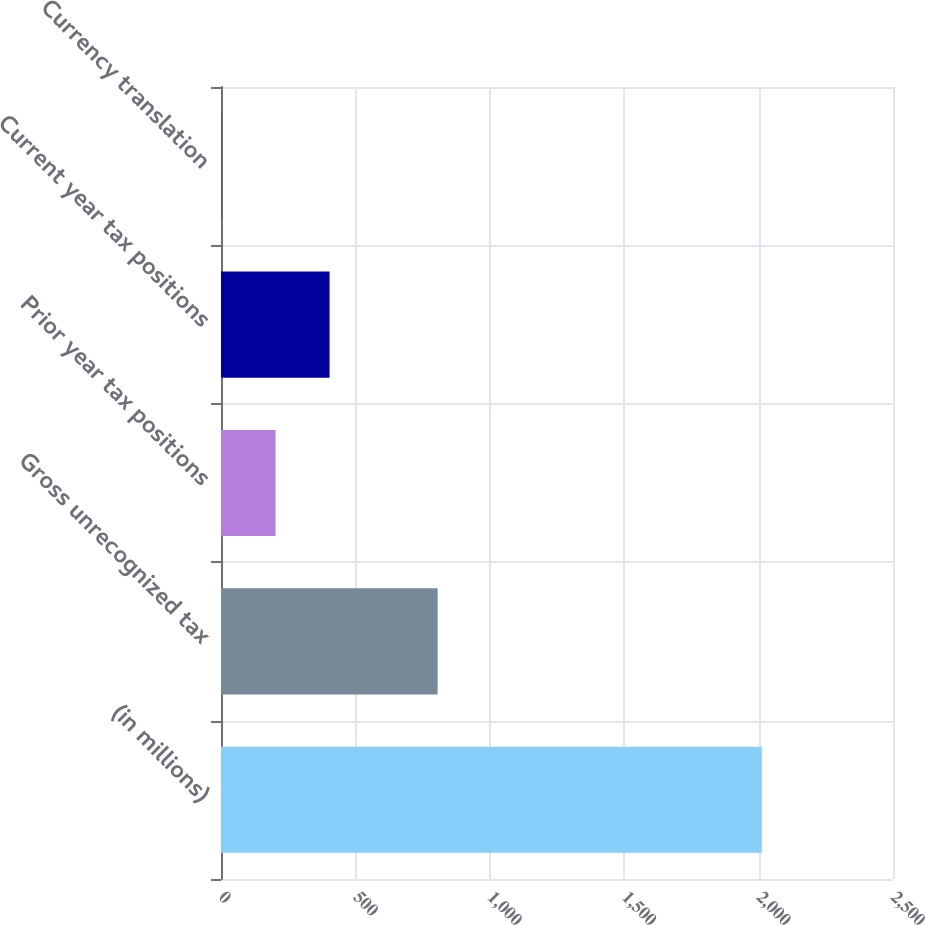<chart> <loc_0><loc_0><loc_500><loc_500><bar_chart><fcel>(in millions)<fcel>Gross unrecognized tax<fcel>Prior year tax positions<fcel>Current year tax positions<fcel>Currency translation<nl><fcel>2012<fcel>805.88<fcel>202.82<fcel>403.84<fcel>1.8<nl></chart> 